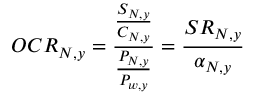<formula> <loc_0><loc_0><loc_500><loc_500>O C R _ { N , y } = \frac { \frac { S _ { N , y } } { C _ { N , y } } } { \frac { P _ { N , y } } { P _ { w , y } } } = \frac { S R _ { N , y } } { \alpha _ { N , y } }</formula> 